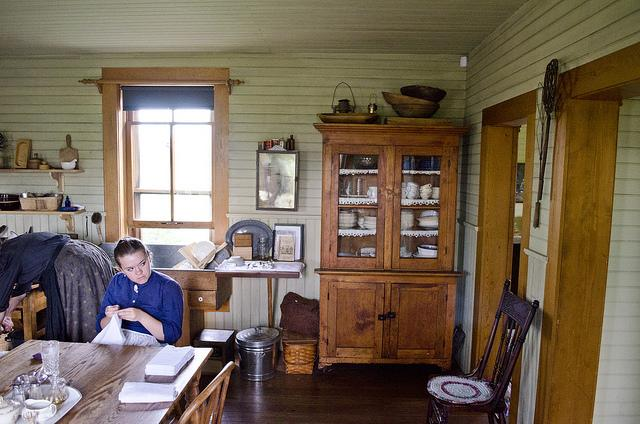What is this woman doing?

Choices:
A) sewing
B) folding napkins
C) tearing
D) plaiting folding napkins 